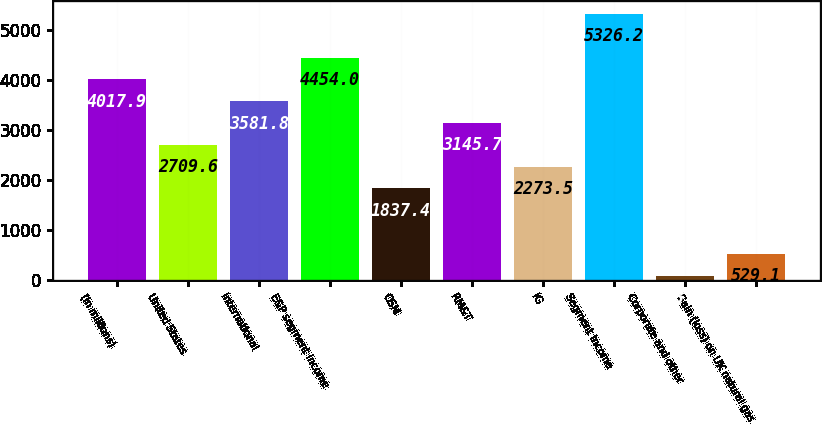<chart> <loc_0><loc_0><loc_500><loc_500><bar_chart><fcel>(In millions)<fcel>United States<fcel>International<fcel>E&P segment income<fcel>OSM<fcel>RM&T<fcel>IG<fcel>Segment income<fcel>Corporate and other<fcel>Gain (loss) on UK natural gas<nl><fcel>4017.9<fcel>2709.6<fcel>3581.8<fcel>4454<fcel>1837.4<fcel>3145.7<fcel>2273.5<fcel>5326.2<fcel>93<fcel>529.1<nl></chart> 